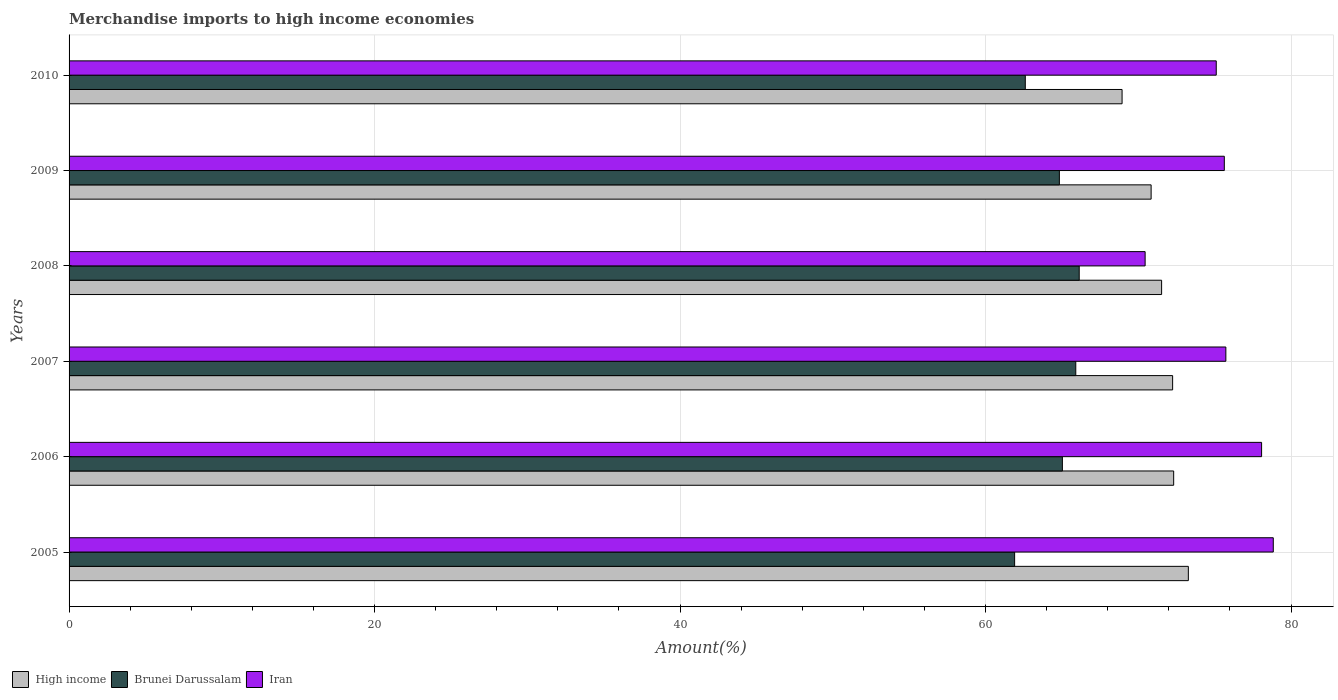Are the number of bars per tick equal to the number of legend labels?
Provide a succinct answer. Yes. How many bars are there on the 5th tick from the top?
Offer a very short reply. 3. In how many cases, is the number of bars for a given year not equal to the number of legend labels?
Offer a very short reply. 0. What is the percentage of amount earned from merchandise imports in Brunei Darussalam in 2006?
Ensure brevity in your answer.  65.03. Across all years, what is the maximum percentage of amount earned from merchandise imports in Brunei Darussalam?
Keep it short and to the point. 66.13. Across all years, what is the minimum percentage of amount earned from merchandise imports in Iran?
Provide a succinct answer. 70.44. In which year was the percentage of amount earned from merchandise imports in Iran maximum?
Your answer should be very brief. 2005. What is the total percentage of amount earned from merchandise imports in High income in the graph?
Provide a succinct answer. 429.13. What is the difference between the percentage of amount earned from merchandise imports in Iran in 2007 and that in 2008?
Keep it short and to the point. 5.29. What is the difference between the percentage of amount earned from merchandise imports in High income in 2006 and the percentage of amount earned from merchandise imports in Brunei Darussalam in 2009?
Provide a short and direct response. 7.48. What is the average percentage of amount earned from merchandise imports in Brunei Darussalam per year?
Provide a short and direct response. 64.4. In the year 2007, what is the difference between the percentage of amount earned from merchandise imports in High income and percentage of amount earned from merchandise imports in Brunei Darussalam?
Your response must be concise. 6.34. In how many years, is the percentage of amount earned from merchandise imports in Iran greater than 12 %?
Give a very brief answer. 6. What is the ratio of the percentage of amount earned from merchandise imports in High income in 2006 to that in 2009?
Your answer should be very brief. 1.02. What is the difference between the highest and the second highest percentage of amount earned from merchandise imports in High income?
Offer a terse response. 0.96. What is the difference between the highest and the lowest percentage of amount earned from merchandise imports in Brunei Darussalam?
Your response must be concise. 4.23. What does the 1st bar from the top in 2009 represents?
Make the answer very short. Iran. What does the 3rd bar from the bottom in 2009 represents?
Your response must be concise. Iran. Is it the case that in every year, the sum of the percentage of amount earned from merchandise imports in High income and percentage of amount earned from merchandise imports in Iran is greater than the percentage of amount earned from merchandise imports in Brunei Darussalam?
Your answer should be very brief. Yes. Are all the bars in the graph horizontal?
Your response must be concise. Yes. How many years are there in the graph?
Your answer should be very brief. 6. Does the graph contain grids?
Your response must be concise. Yes. Where does the legend appear in the graph?
Provide a succinct answer. Bottom left. How are the legend labels stacked?
Ensure brevity in your answer.  Horizontal. What is the title of the graph?
Your answer should be very brief. Merchandise imports to high income economies. Does "Guinea-Bissau" appear as one of the legend labels in the graph?
Keep it short and to the point. No. What is the label or title of the X-axis?
Provide a succinct answer. Amount(%). What is the label or title of the Y-axis?
Ensure brevity in your answer.  Years. What is the Amount(%) of High income in 2005?
Give a very brief answer. 73.27. What is the Amount(%) of Brunei Darussalam in 2005?
Keep it short and to the point. 61.9. What is the Amount(%) of Iran in 2005?
Offer a terse response. 78.83. What is the Amount(%) in High income in 2006?
Offer a terse response. 72.31. What is the Amount(%) of Brunei Darussalam in 2006?
Provide a short and direct response. 65.03. What is the Amount(%) of Iran in 2006?
Make the answer very short. 78.07. What is the Amount(%) of High income in 2007?
Ensure brevity in your answer.  72.25. What is the Amount(%) in Brunei Darussalam in 2007?
Make the answer very short. 65.9. What is the Amount(%) of Iran in 2007?
Your answer should be very brief. 75.73. What is the Amount(%) of High income in 2008?
Keep it short and to the point. 71.52. What is the Amount(%) of Brunei Darussalam in 2008?
Provide a succinct answer. 66.13. What is the Amount(%) of Iran in 2008?
Offer a terse response. 70.44. What is the Amount(%) in High income in 2009?
Provide a short and direct response. 70.84. What is the Amount(%) of Brunei Darussalam in 2009?
Your answer should be compact. 64.83. What is the Amount(%) in Iran in 2009?
Provide a succinct answer. 75.63. What is the Amount(%) in High income in 2010?
Offer a very short reply. 68.94. What is the Amount(%) of Brunei Darussalam in 2010?
Give a very brief answer. 62.6. What is the Amount(%) of Iran in 2010?
Give a very brief answer. 75.1. Across all years, what is the maximum Amount(%) in High income?
Ensure brevity in your answer.  73.27. Across all years, what is the maximum Amount(%) in Brunei Darussalam?
Make the answer very short. 66.13. Across all years, what is the maximum Amount(%) of Iran?
Provide a short and direct response. 78.83. Across all years, what is the minimum Amount(%) of High income?
Make the answer very short. 68.94. Across all years, what is the minimum Amount(%) of Brunei Darussalam?
Make the answer very short. 61.9. Across all years, what is the minimum Amount(%) in Iran?
Offer a very short reply. 70.44. What is the total Amount(%) in High income in the graph?
Offer a terse response. 429.13. What is the total Amount(%) in Brunei Darussalam in the graph?
Your response must be concise. 386.4. What is the total Amount(%) in Iran in the graph?
Your answer should be compact. 453.81. What is the difference between the Amount(%) of High income in 2005 and that in 2006?
Ensure brevity in your answer.  0.96. What is the difference between the Amount(%) in Brunei Darussalam in 2005 and that in 2006?
Your answer should be very brief. -3.13. What is the difference between the Amount(%) of Iran in 2005 and that in 2006?
Offer a very short reply. 0.77. What is the difference between the Amount(%) in High income in 2005 and that in 2007?
Ensure brevity in your answer.  1.03. What is the difference between the Amount(%) of Brunei Darussalam in 2005 and that in 2007?
Ensure brevity in your answer.  -4. What is the difference between the Amount(%) in Iran in 2005 and that in 2007?
Ensure brevity in your answer.  3.1. What is the difference between the Amount(%) of High income in 2005 and that in 2008?
Offer a terse response. 1.75. What is the difference between the Amount(%) in Brunei Darussalam in 2005 and that in 2008?
Offer a terse response. -4.23. What is the difference between the Amount(%) in Iran in 2005 and that in 2008?
Keep it short and to the point. 8.39. What is the difference between the Amount(%) in High income in 2005 and that in 2009?
Make the answer very short. 2.44. What is the difference between the Amount(%) in Brunei Darussalam in 2005 and that in 2009?
Make the answer very short. -2.93. What is the difference between the Amount(%) in Iran in 2005 and that in 2009?
Provide a succinct answer. 3.21. What is the difference between the Amount(%) of High income in 2005 and that in 2010?
Make the answer very short. 4.34. What is the difference between the Amount(%) in Brunei Darussalam in 2005 and that in 2010?
Your response must be concise. -0.7. What is the difference between the Amount(%) of Iran in 2005 and that in 2010?
Provide a succinct answer. 3.73. What is the difference between the Amount(%) in High income in 2006 and that in 2007?
Your response must be concise. 0.07. What is the difference between the Amount(%) in Brunei Darussalam in 2006 and that in 2007?
Ensure brevity in your answer.  -0.88. What is the difference between the Amount(%) of Iran in 2006 and that in 2007?
Make the answer very short. 2.34. What is the difference between the Amount(%) in High income in 2006 and that in 2008?
Your response must be concise. 0.79. What is the difference between the Amount(%) of Brunei Darussalam in 2006 and that in 2008?
Make the answer very short. -1.1. What is the difference between the Amount(%) of Iran in 2006 and that in 2008?
Your answer should be very brief. 7.62. What is the difference between the Amount(%) in High income in 2006 and that in 2009?
Your answer should be very brief. 1.48. What is the difference between the Amount(%) of Brunei Darussalam in 2006 and that in 2009?
Your answer should be compact. 0.2. What is the difference between the Amount(%) in Iran in 2006 and that in 2009?
Provide a short and direct response. 2.44. What is the difference between the Amount(%) of High income in 2006 and that in 2010?
Your answer should be compact. 3.38. What is the difference between the Amount(%) of Brunei Darussalam in 2006 and that in 2010?
Make the answer very short. 2.43. What is the difference between the Amount(%) in Iran in 2006 and that in 2010?
Your answer should be compact. 2.97. What is the difference between the Amount(%) in High income in 2007 and that in 2008?
Provide a succinct answer. 0.72. What is the difference between the Amount(%) of Brunei Darussalam in 2007 and that in 2008?
Give a very brief answer. -0.23. What is the difference between the Amount(%) in Iran in 2007 and that in 2008?
Offer a terse response. 5.29. What is the difference between the Amount(%) of High income in 2007 and that in 2009?
Make the answer very short. 1.41. What is the difference between the Amount(%) of Brunei Darussalam in 2007 and that in 2009?
Provide a succinct answer. 1.07. What is the difference between the Amount(%) in Iran in 2007 and that in 2009?
Your response must be concise. 0.1. What is the difference between the Amount(%) in High income in 2007 and that in 2010?
Make the answer very short. 3.31. What is the difference between the Amount(%) of Brunei Darussalam in 2007 and that in 2010?
Your response must be concise. 3.3. What is the difference between the Amount(%) of Iran in 2007 and that in 2010?
Your response must be concise. 0.63. What is the difference between the Amount(%) of High income in 2008 and that in 2009?
Provide a succinct answer. 0.69. What is the difference between the Amount(%) in Brunei Darussalam in 2008 and that in 2009?
Offer a terse response. 1.3. What is the difference between the Amount(%) of Iran in 2008 and that in 2009?
Your response must be concise. -5.18. What is the difference between the Amount(%) of High income in 2008 and that in 2010?
Your response must be concise. 2.59. What is the difference between the Amount(%) of Brunei Darussalam in 2008 and that in 2010?
Your answer should be compact. 3.53. What is the difference between the Amount(%) in Iran in 2008 and that in 2010?
Your answer should be very brief. -4.66. What is the difference between the Amount(%) of High income in 2009 and that in 2010?
Ensure brevity in your answer.  1.9. What is the difference between the Amount(%) of Brunei Darussalam in 2009 and that in 2010?
Provide a succinct answer. 2.23. What is the difference between the Amount(%) of Iran in 2009 and that in 2010?
Provide a short and direct response. 0.53. What is the difference between the Amount(%) in High income in 2005 and the Amount(%) in Brunei Darussalam in 2006?
Provide a short and direct response. 8.25. What is the difference between the Amount(%) of High income in 2005 and the Amount(%) of Iran in 2006?
Offer a very short reply. -4.8. What is the difference between the Amount(%) of Brunei Darussalam in 2005 and the Amount(%) of Iran in 2006?
Offer a terse response. -16.17. What is the difference between the Amount(%) in High income in 2005 and the Amount(%) in Brunei Darussalam in 2007?
Ensure brevity in your answer.  7.37. What is the difference between the Amount(%) in High income in 2005 and the Amount(%) in Iran in 2007?
Provide a succinct answer. -2.46. What is the difference between the Amount(%) of Brunei Darussalam in 2005 and the Amount(%) of Iran in 2007?
Your response must be concise. -13.83. What is the difference between the Amount(%) in High income in 2005 and the Amount(%) in Brunei Darussalam in 2008?
Ensure brevity in your answer.  7.14. What is the difference between the Amount(%) of High income in 2005 and the Amount(%) of Iran in 2008?
Provide a succinct answer. 2.83. What is the difference between the Amount(%) in Brunei Darussalam in 2005 and the Amount(%) in Iran in 2008?
Keep it short and to the point. -8.54. What is the difference between the Amount(%) of High income in 2005 and the Amount(%) of Brunei Darussalam in 2009?
Offer a terse response. 8.44. What is the difference between the Amount(%) in High income in 2005 and the Amount(%) in Iran in 2009?
Your answer should be very brief. -2.35. What is the difference between the Amount(%) of Brunei Darussalam in 2005 and the Amount(%) of Iran in 2009?
Offer a terse response. -13.73. What is the difference between the Amount(%) of High income in 2005 and the Amount(%) of Brunei Darussalam in 2010?
Your response must be concise. 10.67. What is the difference between the Amount(%) in High income in 2005 and the Amount(%) in Iran in 2010?
Ensure brevity in your answer.  -1.83. What is the difference between the Amount(%) in Brunei Darussalam in 2005 and the Amount(%) in Iran in 2010?
Keep it short and to the point. -13.2. What is the difference between the Amount(%) in High income in 2006 and the Amount(%) in Brunei Darussalam in 2007?
Offer a very short reply. 6.41. What is the difference between the Amount(%) of High income in 2006 and the Amount(%) of Iran in 2007?
Your answer should be compact. -3.42. What is the difference between the Amount(%) of Brunei Darussalam in 2006 and the Amount(%) of Iran in 2007?
Your answer should be compact. -10.7. What is the difference between the Amount(%) of High income in 2006 and the Amount(%) of Brunei Darussalam in 2008?
Ensure brevity in your answer.  6.18. What is the difference between the Amount(%) of High income in 2006 and the Amount(%) of Iran in 2008?
Provide a short and direct response. 1.87. What is the difference between the Amount(%) in Brunei Darussalam in 2006 and the Amount(%) in Iran in 2008?
Your answer should be compact. -5.42. What is the difference between the Amount(%) in High income in 2006 and the Amount(%) in Brunei Darussalam in 2009?
Your response must be concise. 7.48. What is the difference between the Amount(%) of High income in 2006 and the Amount(%) of Iran in 2009?
Ensure brevity in your answer.  -3.32. What is the difference between the Amount(%) in Brunei Darussalam in 2006 and the Amount(%) in Iran in 2009?
Ensure brevity in your answer.  -10.6. What is the difference between the Amount(%) in High income in 2006 and the Amount(%) in Brunei Darussalam in 2010?
Offer a terse response. 9.71. What is the difference between the Amount(%) of High income in 2006 and the Amount(%) of Iran in 2010?
Make the answer very short. -2.79. What is the difference between the Amount(%) of Brunei Darussalam in 2006 and the Amount(%) of Iran in 2010?
Your response must be concise. -10.07. What is the difference between the Amount(%) of High income in 2007 and the Amount(%) of Brunei Darussalam in 2008?
Give a very brief answer. 6.11. What is the difference between the Amount(%) of High income in 2007 and the Amount(%) of Iran in 2008?
Give a very brief answer. 1.8. What is the difference between the Amount(%) of Brunei Darussalam in 2007 and the Amount(%) of Iran in 2008?
Your answer should be compact. -4.54. What is the difference between the Amount(%) of High income in 2007 and the Amount(%) of Brunei Darussalam in 2009?
Provide a succinct answer. 7.41. What is the difference between the Amount(%) of High income in 2007 and the Amount(%) of Iran in 2009?
Provide a short and direct response. -3.38. What is the difference between the Amount(%) in Brunei Darussalam in 2007 and the Amount(%) in Iran in 2009?
Make the answer very short. -9.72. What is the difference between the Amount(%) in High income in 2007 and the Amount(%) in Brunei Darussalam in 2010?
Provide a succinct answer. 9.65. What is the difference between the Amount(%) in High income in 2007 and the Amount(%) in Iran in 2010?
Give a very brief answer. -2.86. What is the difference between the Amount(%) in Brunei Darussalam in 2007 and the Amount(%) in Iran in 2010?
Your answer should be very brief. -9.2. What is the difference between the Amount(%) in High income in 2008 and the Amount(%) in Brunei Darussalam in 2009?
Make the answer very short. 6.69. What is the difference between the Amount(%) in High income in 2008 and the Amount(%) in Iran in 2009?
Provide a short and direct response. -4.1. What is the difference between the Amount(%) in Brunei Darussalam in 2008 and the Amount(%) in Iran in 2009?
Provide a succinct answer. -9.5. What is the difference between the Amount(%) in High income in 2008 and the Amount(%) in Brunei Darussalam in 2010?
Your response must be concise. 8.92. What is the difference between the Amount(%) in High income in 2008 and the Amount(%) in Iran in 2010?
Provide a short and direct response. -3.58. What is the difference between the Amount(%) of Brunei Darussalam in 2008 and the Amount(%) of Iran in 2010?
Provide a succinct answer. -8.97. What is the difference between the Amount(%) of High income in 2009 and the Amount(%) of Brunei Darussalam in 2010?
Your answer should be very brief. 8.24. What is the difference between the Amount(%) in High income in 2009 and the Amount(%) in Iran in 2010?
Give a very brief answer. -4.26. What is the difference between the Amount(%) of Brunei Darussalam in 2009 and the Amount(%) of Iran in 2010?
Your answer should be compact. -10.27. What is the average Amount(%) in High income per year?
Keep it short and to the point. 71.52. What is the average Amount(%) of Brunei Darussalam per year?
Give a very brief answer. 64.4. What is the average Amount(%) of Iran per year?
Your answer should be very brief. 75.63. In the year 2005, what is the difference between the Amount(%) in High income and Amount(%) in Brunei Darussalam?
Make the answer very short. 11.37. In the year 2005, what is the difference between the Amount(%) of High income and Amount(%) of Iran?
Provide a succinct answer. -5.56. In the year 2005, what is the difference between the Amount(%) in Brunei Darussalam and Amount(%) in Iran?
Give a very brief answer. -16.93. In the year 2006, what is the difference between the Amount(%) of High income and Amount(%) of Brunei Darussalam?
Ensure brevity in your answer.  7.29. In the year 2006, what is the difference between the Amount(%) in High income and Amount(%) in Iran?
Make the answer very short. -5.76. In the year 2006, what is the difference between the Amount(%) of Brunei Darussalam and Amount(%) of Iran?
Offer a terse response. -13.04. In the year 2007, what is the difference between the Amount(%) in High income and Amount(%) in Brunei Darussalam?
Offer a terse response. 6.34. In the year 2007, what is the difference between the Amount(%) in High income and Amount(%) in Iran?
Give a very brief answer. -3.48. In the year 2007, what is the difference between the Amount(%) in Brunei Darussalam and Amount(%) in Iran?
Your response must be concise. -9.83. In the year 2008, what is the difference between the Amount(%) of High income and Amount(%) of Brunei Darussalam?
Offer a terse response. 5.39. In the year 2008, what is the difference between the Amount(%) of High income and Amount(%) of Iran?
Give a very brief answer. 1.08. In the year 2008, what is the difference between the Amount(%) of Brunei Darussalam and Amount(%) of Iran?
Make the answer very short. -4.31. In the year 2009, what is the difference between the Amount(%) of High income and Amount(%) of Brunei Darussalam?
Provide a succinct answer. 6.01. In the year 2009, what is the difference between the Amount(%) of High income and Amount(%) of Iran?
Your response must be concise. -4.79. In the year 2009, what is the difference between the Amount(%) of Brunei Darussalam and Amount(%) of Iran?
Ensure brevity in your answer.  -10.8. In the year 2010, what is the difference between the Amount(%) of High income and Amount(%) of Brunei Darussalam?
Keep it short and to the point. 6.34. In the year 2010, what is the difference between the Amount(%) of High income and Amount(%) of Iran?
Offer a terse response. -6.17. In the year 2010, what is the difference between the Amount(%) of Brunei Darussalam and Amount(%) of Iran?
Provide a succinct answer. -12.5. What is the ratio of the Amount(%) in High income in 2005 to that in 2006?
Offer a terse response. 1.01. What is the ratio of the Amount(%) of Brunei Darussalam in 2005 to that in 2006?
Your answer should be very brief. 0.95. What is the ratio of the Amount(%) in Iran in 2005 to that in 2006?
Your response must be concise. 1.01. What is the ratio of the Amount(%) in High income in 2005 to that in 2007?
Your response must be concise. 1.01. What is the ratio of the Amount(%) of Brunei Darussalam in 2005 to that in 2007?
Your answer should be compact. 0.94. What is the ratio of the Amount(%) of Iran in 2005 to that in 2007?
Your response must be concise. 1.04. What is the ratio of the Amount(%) in High income in 2005 to that in 2008?
Your answer should be compact. 1.02. What is the ratio of the Amount(%) in Brunei Darussalam in 2005 to that in 2008?
Your answer should be compact. 0.94. What is the ratio of the Amount(%) of Iran in 2005 to that in 2008?
Provide a short and direct response. 1.12. What is the ratio of the Amount(%) of High income in 2005 to that in 2009?
Provide a succinct answer. 1.03. What is the ratio of the Amount(%) in Brunei Darussalam in 2005 to that in 2009?
Offer a terse response. 0.95. What is the ratio of the Amount(%) of Iran in 2005 to that in 2009?
Ensure brevity in your answer.  1.04. What is the ratio of the Amount(%) of High income in 2005 to that in 2010?
Your response must be concise. 1.06. What is the ratio of the Amount(%) of Brunei Darussalam in 2005 to that in 2010?
Your answer should be compact. 0.99. What is the ratio of the Amount(%) in Iran in 2005 to that in 2010?
Your answer should be compact. 1.05. What is the ratio of the Amount(%) of High income in 2006 to that in 2007?
Your answer should be compact. 1. What is the ratio of the Amount(%) of Brunei Darussalam in 2006 to that in 2007?
Your response must be concise. 0.99. What is the ratio of the Amount(%) of Iran in 2006 to that in 2007?
Your answer should be compact. 1.03. What is the ratio of the Amount(%) of Brunei Darussalam in 2006 to that in 2008?
Your answer should be compact. 0.98. What is the ratio of the Amount(%) in Iran in 2006 to that in 2008?
Ensure brevity in your answer.  1.11. What is the ratio of the Amount(%) in High income in 2006 to that in 2009?
Your answer should be compact. 1.02. What is the ratio of the Amount(%) of Brunei Darussalam in 2006 to that in 2009?
Your answer should be compact. 1. What is the ratio of the Amount(%) of Iran in 2006 to that in 2009?
Offer a very short reply. 1.03. What is the ratio of the Amount(%) of High income in 2006 to that in 2010?
Provide a succinct answer. 1.05. What is the ratio of the Amount(%) of Brunei Darussalam in 2006 to that in 2010?
Give a very brief answer. 1.04. What is the ratio of the Amount(%) of Iran in 2006 to that in 2010?
Offer a very short reply. 1.04. What is the ratio of the Amount(%) in Brunei Darussalam in 2007 to that in 2008?
Your answer should be very brief. 1. What is the ratio of the Amount(%) of Iran in 2007 to that in 2008?
Offer a very short reply. 1.07. What is the ratio of the Amount(%) of High income in 2007 to that in 2009?
Ensure brevity in your answer.  1.02. What is the ratio of the Amount(%) in Brunei Darussalam in 2007 to that in 2009?
Provide a succinct answer. 1.02. What is the ratio of the Amount(%) in Iran in 2007 to that in 2009?
Your answer should be compact. 1. What is the ratio of the Amount(%) of High income in 2007 to that in 2010?
Offer a very short reply. 1.05. What is the ratio of the Amount(%) of Brunei Darussalam in 2007 to that in 2010?
Provide a succinct answer. 1.05. What is the ratio of the Amount(%) in Iran in 2007 to that in 2010?
Your answer should be very brief. 1.01. What is the ratio of the Amount(%) of High income in 2008 to that in 2009?
Your answer should be very brief. 1.01. What is the ratio of the Amount(%) of Brunei Darussalam in 2008 to that in 2009?
Ensure brevity in your answer.  1.02. What is the ratio of the Amount(%) of Iran in 2008 to that in 2009?
Keep it short and to the point. 0.93. What is the ratio of the Amount(%) of High income in 2008 to that in 2010?
Ensure brevity in your answer.  1.04. What is the ratio of the Amount(%) of Brunei Darussalam in 2008 to that in 2010?
Provide a succinct answer. 1.06. What is the ratio of the Amount(%) in Iran in 2008 to that in 2010?
Keep it short and to the point. 0.94. What is the ratio of the Amount(%) in High income in 2009 to that in 2010?
Ensure brevity in your answer.  1.03. What is the ratio of the Amount(%) of Brunei Darussalam in 2009 to that in 2010?
Your response must be concise. 1.04. What is the difference between the highest and the second highest Amount(%) in High income?
Provide a short and direct response. 0.96. What is the difference between the highest and the second highest Amount(%) of Brunei Darussalam?
Ensure brevity in your answer.  0.23. What is the difference between the highest and the second highest Amount(%) of Iran?
Keep it short and to the point. 0.77. What is the difference between the highest and the lowest Amount(%) in High income?
Your answer should be very brief. 4.34. What is the difference between the highest and the lowest Amount(%) in Brunei Darussalam?
Offer a very short reply. 4.23. What is the difference between the highest and the lowest Amount(%) of Iran?
Your answer should be compact. 8.39. 